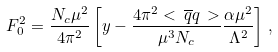Convert formula to latex. <formula><loc_0><loc_0><loc_500><loc_500>F _ { 0 } ^ { 2 } = \frac { N _ { c } \mu ^ { 2 } } { 4 \pi ^ { 2 } } \left [ y - \frac { 4 \pi ^ { 2 } < \, \overline { q } q \, > } { \mu ^ { 3 } N _ { c } } \frac { \alpha \mu ^ { 2 } } { \Lambda ^ { 2 } } \right ] \, ,</formula> 